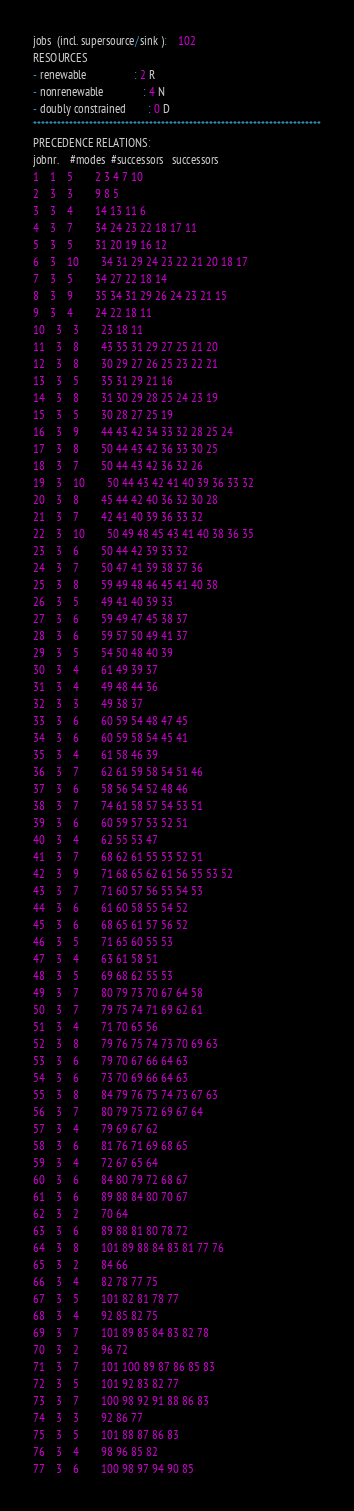Convert code to text. <code><loc_0><loc_0><loc_500><loc_500><_ObjectiveC_>jobs  (incl. supersource/sink ):	102
RESOURCES
- renewable                 : 2 R
- nonrenewable              : 4 N
- doubly constrained        : 0 D
************************************************************************
PRECEDENCE RELATIONS:
jobnr.    #modes  #successors   successors
1	1	5		2 3 4 7 10 
2	3	3		9 8 5 
3	3	4		14 13 11 6 
4	3	7		34 24 23 22 18 17 11 
5	3	5		31 20 19 16 12 
6	3	10		34 31 29 24 23 22 21 20 18 17 
7	3	5		34 27 22 18 14 
8	3	9		35 34 31 29 26 24 23 21 15 
9	3	4		24 22 18 11 
10	3	3		23 18 11 
11	3	8		43 35 31 29 27 25 21 20 
12	3	8		30 29 27 26 25 23 22 21 
13	3	5		35 31 29 21 16 
14	3	8		31 30 29 28 25 24 23 19 
15	3	5		30 28 27 25 19 
16	3	9		44 43 42 34 33 32 28 25 24 
17	3	8		50 44 43 42 36 33 30 25 
18	3	7		50 44 43 42 36 32 26 
19	3	10		50 44 43 42 41 40 39 36 33 32 
20	3	8		45 44 42 40 36 32 30 28 
21	3	7		42 41 40 39 36 33 32 
22	3	10		50 49 48 45 43 41 40 38 36 35 
23	3	6		50 44 42 39 33 32 
24	3	7		50 47 41 39 38 37 36 
25	3	8		59 49 48 46 45 41 40 38 
26	3	5		49 41 40 39 33 
27	3	6		59 49 47 45 38 37 
28	3	6		59 57 50 49 41 37 
29	3	5		54 50 48 40 39 
30	3	4		61 49 39 37 
31	3	4		49 48 44 36 
32	3	3		49 38 37 
33	3	6		60 59 54 48 47 45 
34	3	6		60 59 58 54 45 41 
35	3	4		61 58 46 39 
36	3	7		62 61 59 58 54 51 46 
37	3	6		58 56 54 52 48 46 
38	3	7		74 61 58 57 54 53 51 
39	3	6		60 59 57 53 52 51 
40	3	4		62 55 53 47 
41	3	7		68 62 61 55 53 52 51 
42	3	9		71 68 65 62 61 56 55 53 52 
43	3	7		71 60 57 56 55 54 53 
44	3	6		61 60 58 55 54 52 
45	3	6		68 65 61 57 56 52 
46	3	5		71 65 60 55 53 
47	3	4		63 61 58 51 
48	3	5		69 68 62 55 53 
49	3	7		80 79 73 70 67 64 58 
50	3	7		79 75 74 71 69 62 61 
51	3	4		71 70 65 56 
52	3	8		79 76 75 74 73 70 69 63 
53	3	6		79 70 67 66 64 63 
54	3	6		73 70 69 66 64 63 
55	3	8		84 79 76 75 74 73 67 63 
56	3	7		80 79 75 72 69 67 64 
57	3	4		79 69 67 62 
58	3	6		81 76 71 69 68 65 
59	3	4		72 67 65 64 
60	3	6		84 80 79 72 68 67 
61	3	6		89 88 84 80 70 67 
62	3	2		70 64 
63	3	6		89 88 81 80 78 72 
64	3	8		101 89 88 84 83 81 77 76 
65	3	2		84 66 
66	3	4		82 78 77 75 
67	3	5		101 82 81 78 77 
68	3	4		92 85 82 75 
69	3	7		101 89 85 84 83 82 78 
70	3	2		96 72 
71	3	7		101 100 89 87 86 85 83 
72	3	5		101 92 83 82 77 
73	3	7		100 98 92 91 88 86 83 
74	3	3		92 86 77 
75	3	5		101 88 87 86 83 
76	3	4		98 96 85 82 
77	3	6		100 98 97 94 90 85 </code> 